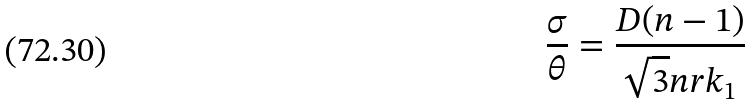Convert formula to latex. <formula><loc_0><loc_0><loc_500><loc_500>\frac { \sigma } { \theta } = \frac { D ( n - 1 ) } { \sqrt { 3 } n r k _ { 1 } }</formula> 